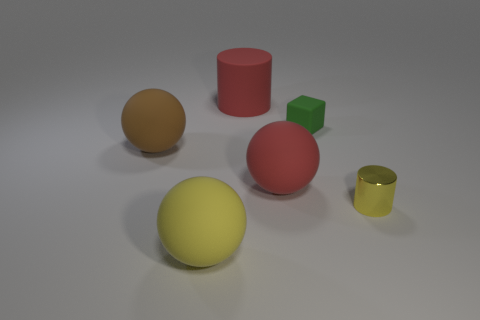There is a matte ball that is the same color as the big cylinder; what size is it?
Give a very brief answer. Large. How many other objects are there of the same size as the brown rubber object?
Your answer should be compact. 3. Is the yellow object that is behind the yellow sphere made of the same material as the green object?
Ensure brevity in your answer.  No. What number of other things are the same color as the block?
Offer a terse response. 0. What number of other things are the same shape as the big yellow thing?
Make the answer very short. 2. There is a yellow object that is to the left of the green rubber cube; does it have the same shape as the big red rubber object on the right side of the large matte cylinder?
Provide a succinct answer. Yes. Is the number of spheres to the left of the red rubber ball the same as the number of small rubber cubes that are in front of the small green thing?
Offer a very short reply. No. The large red thing in front of the sphere that is to the left of the big yellow ball on the left side of the small green object is what shape?
Offer a very short reply. Sphere. Do the red object that is behind the brown sphere and the large red object that is to the right of the red rubber cylinder have the same material?
Ensure brevity in your answer.  Yes. The red rubber object behind the matte block has what shape?
Make the answer very short. Cylinder. 